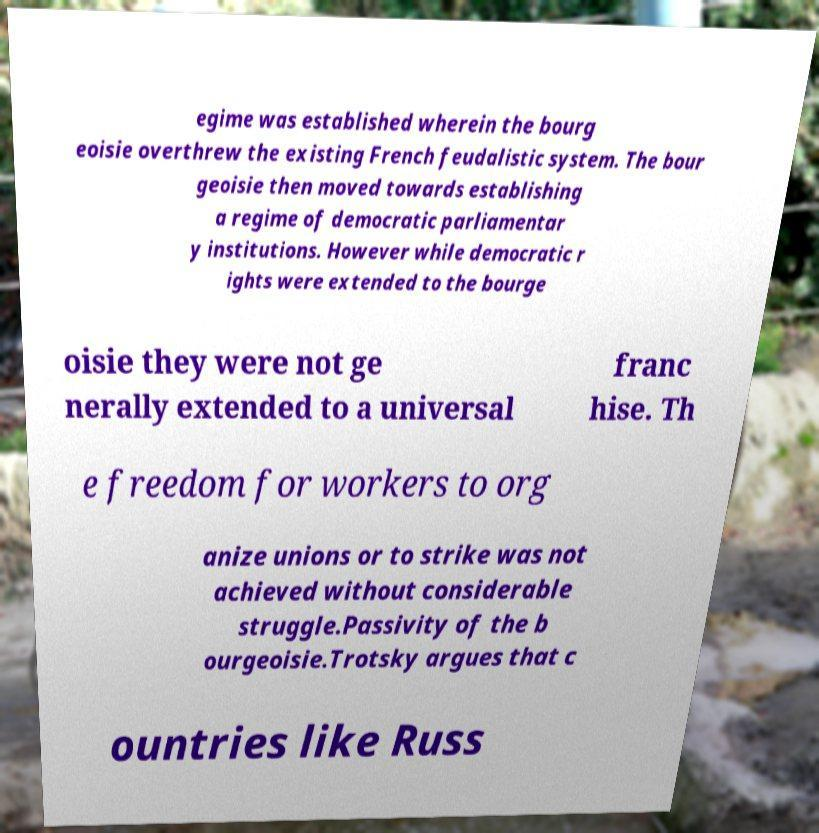For documentation purposes, I need the text within this image transcribed. Could you provide that? egime was established wherein the bourg eoisie overthrew the existing French feudalistic system. The bour geoisie then moved towards establishing a regime of democratic parliamentar y institutions. However while democratic r ights were extended to the bourge oisie they were not ge nerally extended to a universal franc hise. Th e freedom for workers to org anize unions or to strike was not achieved without considerable struggle.Passivity of the b ourgeoisie.Trotsky argues that c ountries like Russ 